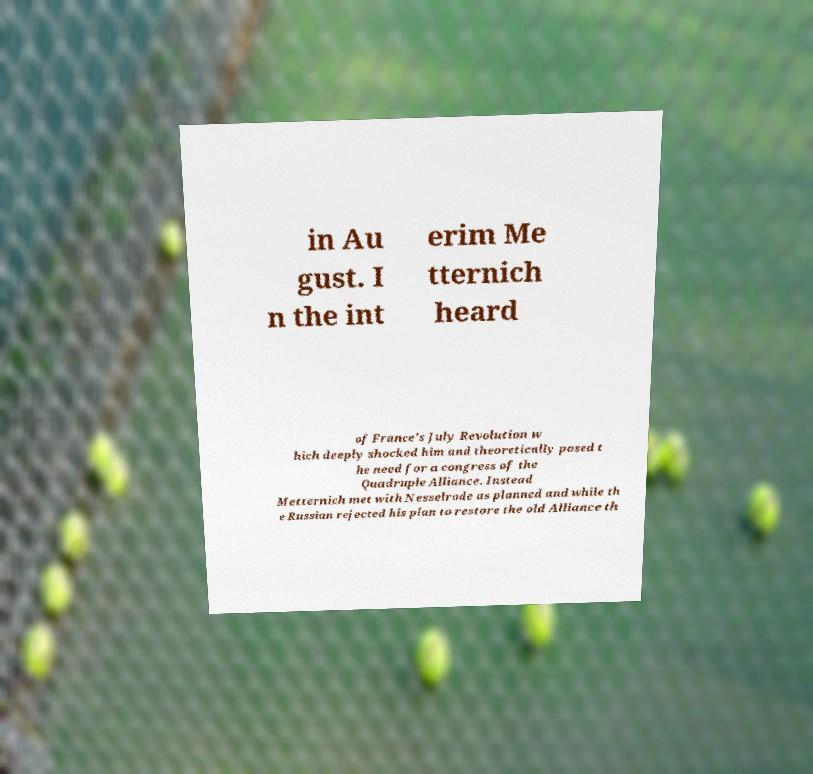What messages or text are displayed in this image? I need them in a readable, typed format. in Au gust. I n the int erim Me tternich heard of France's July Revolution w hich deeply shocked him and theoretically posed t he need for a congress of the Quadruple Alliance. Instead Metternich met with Nesselrode as planned and while th e Russian rejected his plan to restore the old Alliance th 